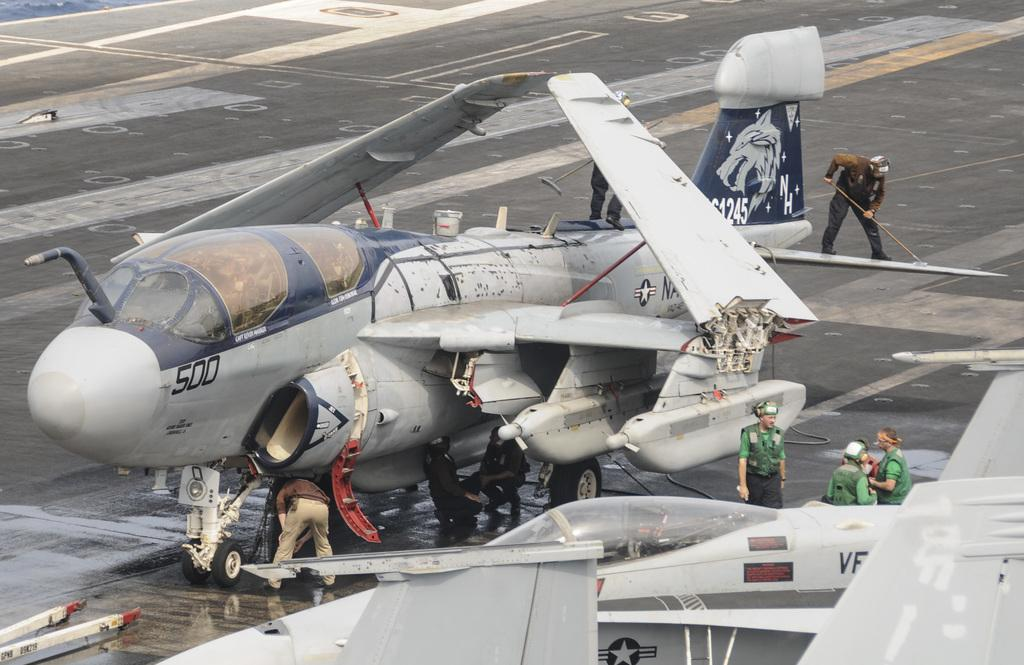<image>
Offer a succinct explanation of the picture presented. An airplane with the number 500 on it is having maintenance performed on a runway. 